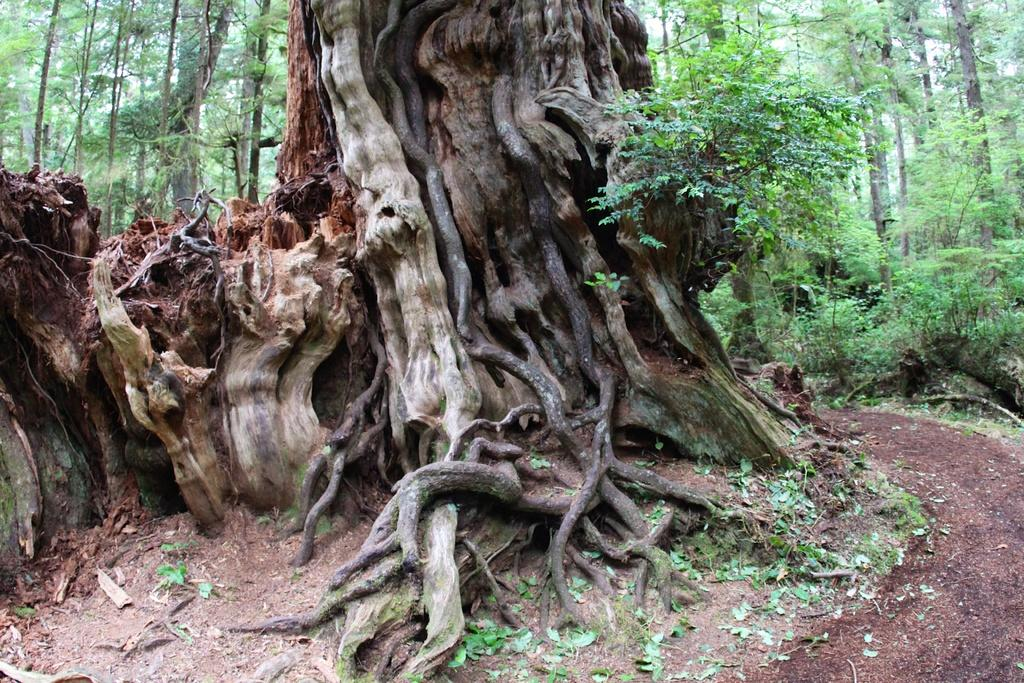What type of vegetation is in the center of the image? There are trees, grass, and plants in the center of the image. Can you describe the landscape in the center of the image? The landscape in the center of the center of the image consists of trees, grass, and plants. What is the primary color of the landscape in the center of the image? The primary color of the landscape in the center of the image is green, due to the presence of grass and plants. How many eggs are visible in the center of the image? There are no eggs present in the image; it features a landscape with trees, grass, and plants. What type of adjustment can be made to the size of the trees in the image? There is no adjustment possible to the size of the trees in the image, as it is a static representation of the landscape. 